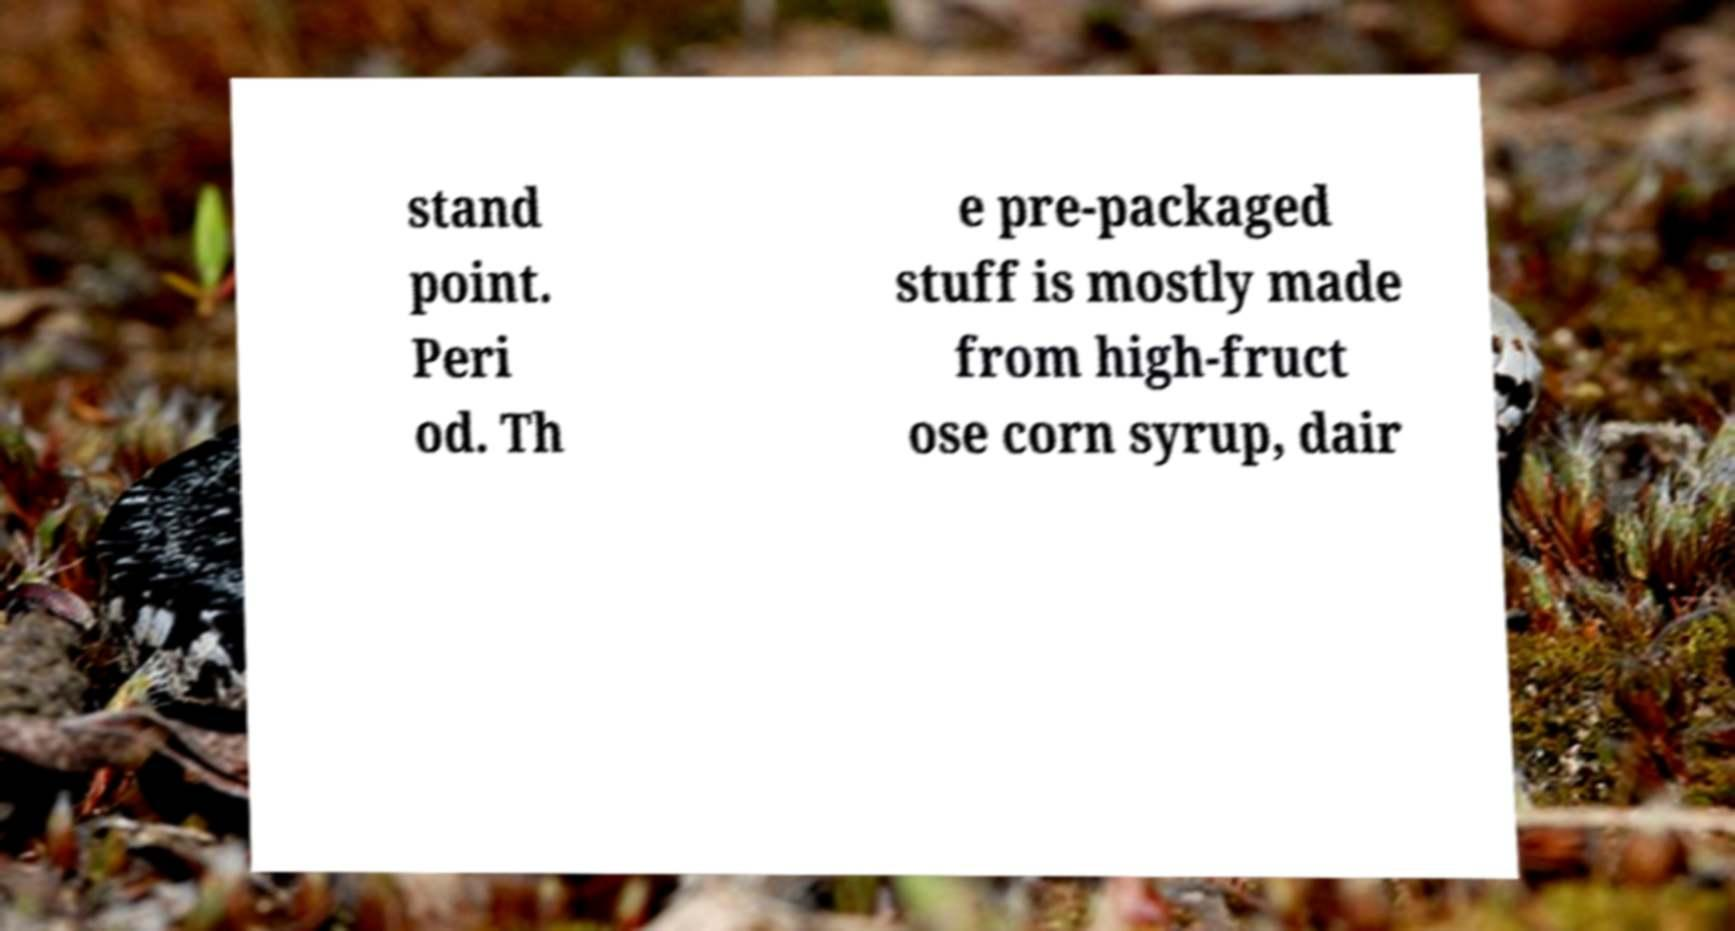Please identify and transcribe the text found in this image. stand point. Peri od. Th e pre-packaged stuff is mostly made from high-fruct ose corn syrup, dair 